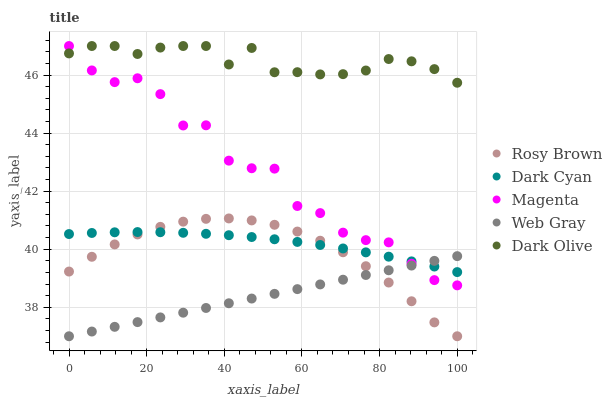Does Web Gray have the minimum area under the curve?
Answer yes or no. Yes. Does Dark Olive have the maximum area under the curve?
Answer yes or no. Yes. Does Magenta have the minimum area under the curve?
Answer yes or no. No. Does Magenta have the maximum area under the curve?
Answer yes or no. No. Is Web Gray the smoothest?
Answer yes or no. Yes. Is Magenta the roughest?
Answer yes or no. Yes. Is Rosy Brown the smoothest?
Answer yes or no. No. Is Rosy Brown the roughest?
Answer yes or no. No. Does Rosy Brown have the lowest value?
Answer yes or no. Yes. Does Magenta have the lowest value?
Answer yes or no. No. Does Dark Olive have the highest value?
Answer yes or no. Yes. Does Rosy Brown have the highest value?
Answer yes or no. No. Is Dark Cyan less than Dark Olive?
Answer yes or no. Yes. Is Magenta greater than Rosy Brown?
Answer yes or no. Yes. Does Dark Cyan intersect Rosy Brown?
Answer yes or no. Yes. Is Dark Cyan less than Rosy Brown?
Answer yes or no. No. Is Dark Cyan greater than Rosy Brown?
Answer yes or no. No. Does Dark Cyan intersect Dark Olive?
Answer yes or no. No. 